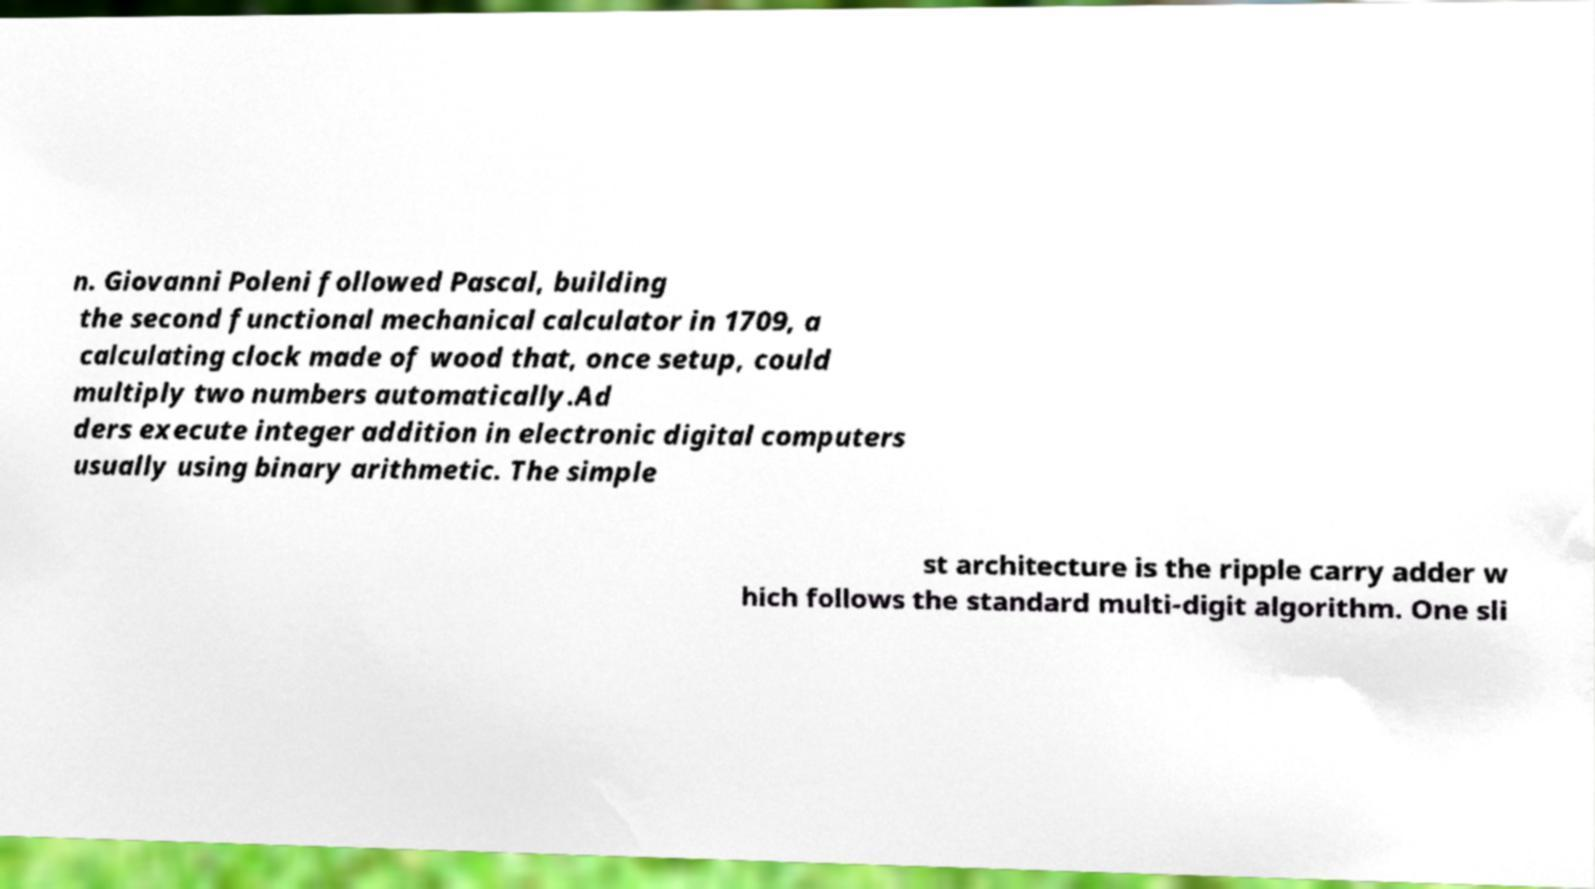For documentation purposes, I need the text within this image transcribed. Could you provide that? n. Giovanni Poleni followed Pascal, building the second functional mechanical calculator in 1709, a calculating clock made of wood that, once setup, could multiply two numbers automatically.Ad ders execute integer addition in electronic digital computers usually using binary arithmetic. The simple st architecture is the ripple carry adder w hich follows the standard multi-digit algorithm. One sli 